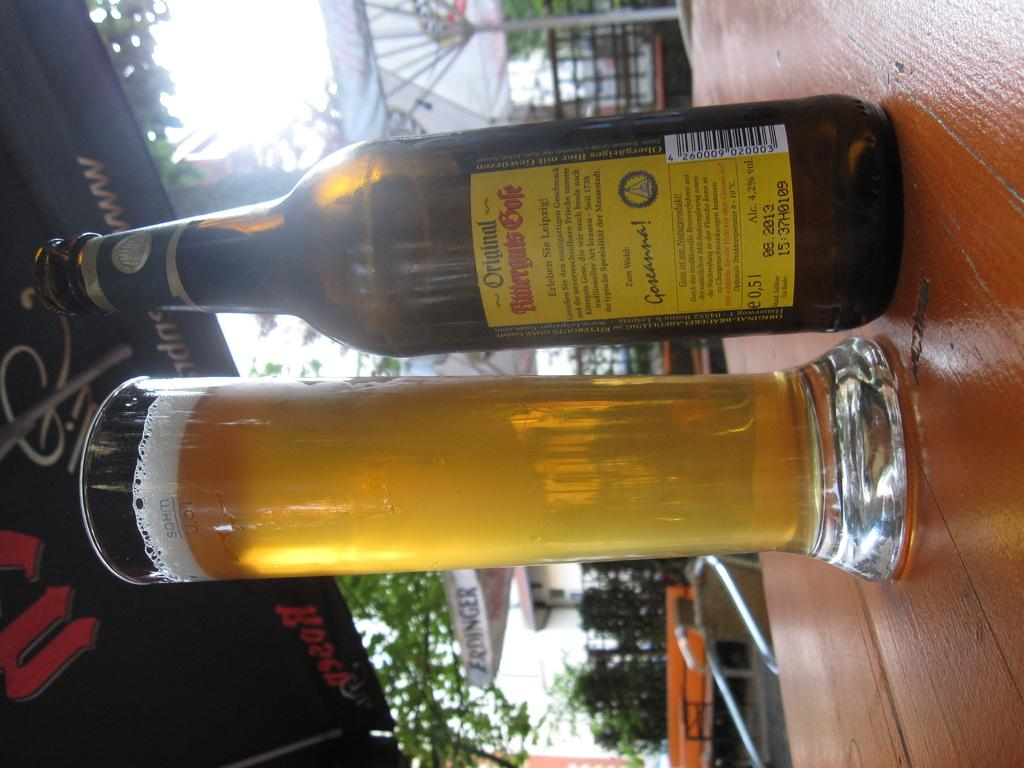<image>
Describe the image concisely. a bottle and a glass with the bottle saying original on it 